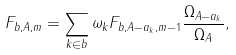<formula> <loc_0><loc_0><loc_500><loc_500>F _ { b , A , m } = \sum _ { k \in b } \omega _ { k } F _ { b , A - a _ { k } , m - 1 } \frac { \Omega _ { A - a _ { k } } } { \Omega _ { A } } ,</formula> 